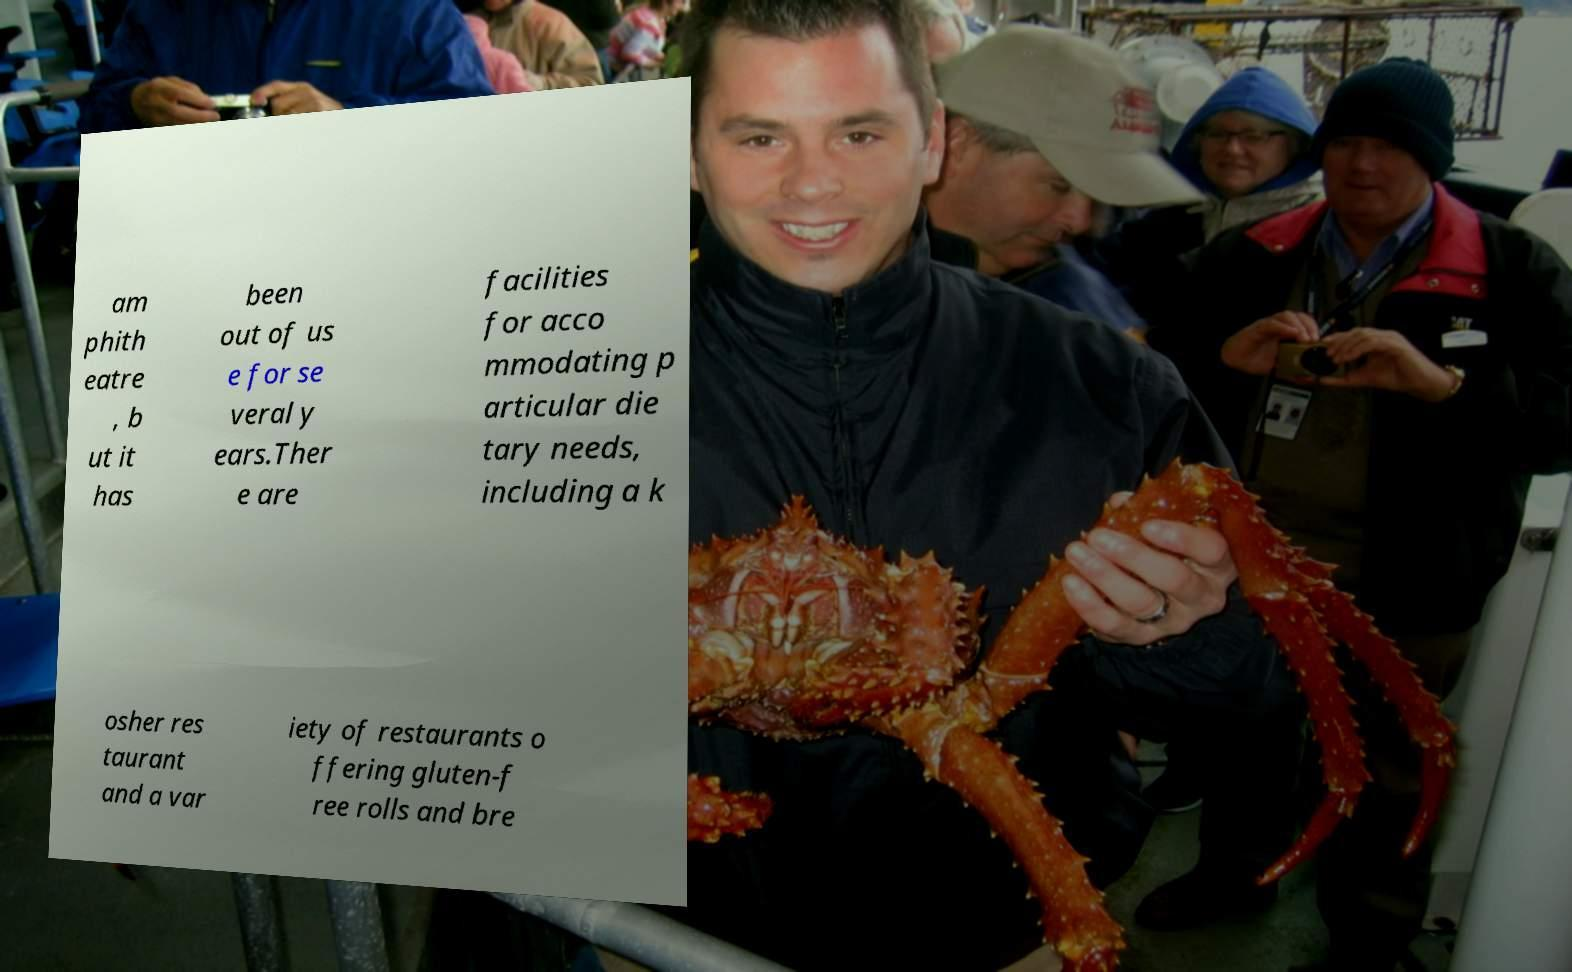There's text embedded in this image that I need extracted. Can you transcribe it verbatim? am phith eatre , b ut it has been out of us e for se veral y ears.Ther e are facilities for acco mmodating p articular die tary needs, including a k osher res taurant and a var iety of restaurants o ffering gluten-f ree rolls and bre 